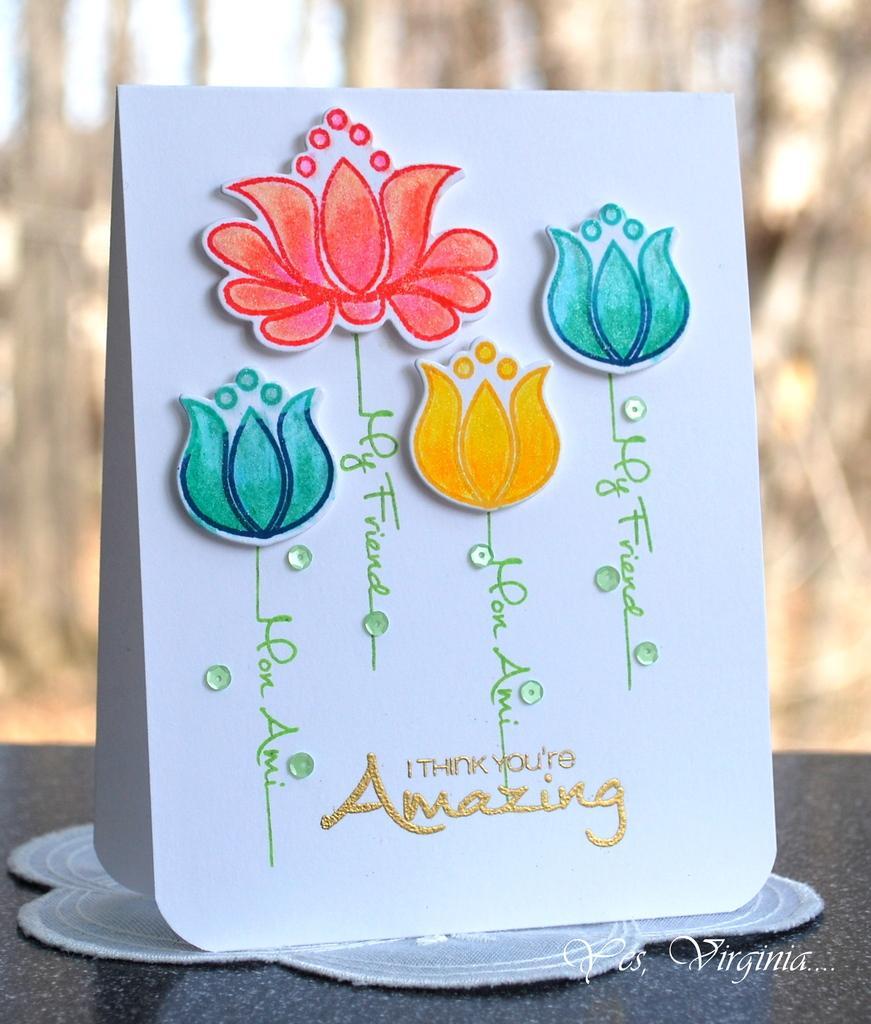How would you summarize this image in a sentence or two? In this image I can see a gift card on the table and a text. This image is taken during a day. 